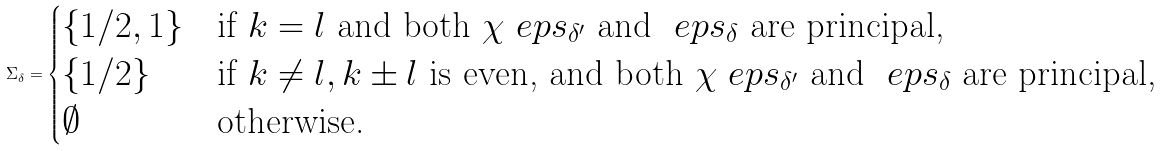Convert formula to latex. <formula><loc_0><loc_0><loc_500><loc_500>\Sigma _ { \delta } = \begin{cases} \{ 1 / 2 , 1 \} & \text {if } k = l \text { and both } \chi \ e p s _ { \delta ^ { \prime } } \text { and } \ e p s _ { \delta } \text { are principal,} \\ \{ 1 / 2 \} & \text {if } k \neq l , k \pm l \text { is even, and both } \chi \ e p s _ { \delta ^ { \prime } } \text { and } \ e p s _ { \delta } \text { are principal,} \\ \emptyset & \text {otherwise.} \end{cases}</formula> 